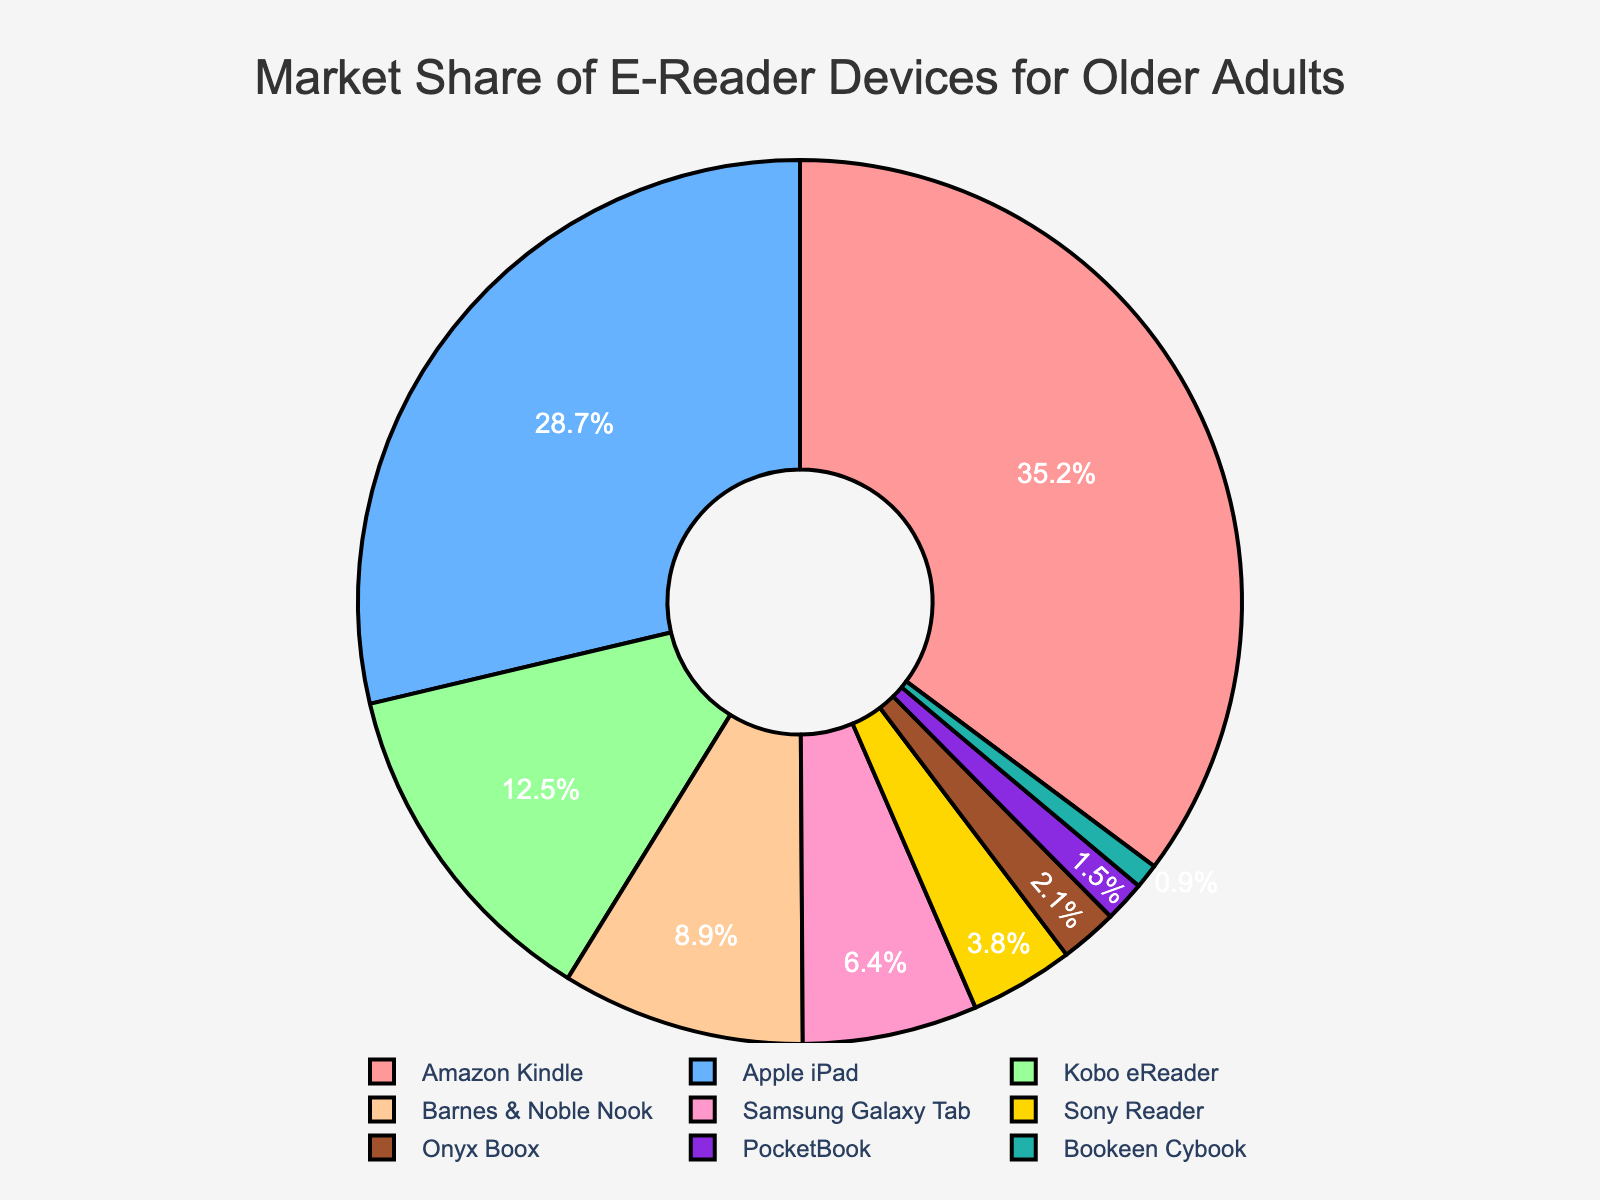Which device has the highest market share? By looking at the pie chart, the largest segment corresponds to the Amazon Kindle.
Answer: Amazon Kindle Which device has the second highest market share? The second-largest segment in the pie chart corresponds to the Apple iPad.
Answer: Apple iPad What is the combined market share of the Amazon Kindle and Apple iPad? The market share of Amazon Kindle is 35.2%, and Apple iPad is 28.7%. Adding them together gives: 35.2 + 28.7 = 63.9%.
Answer: 63.9% How much higher is the market share of the Amazon Kindle compared to the Kobo eReader? The market share of Amazon Kindle is 35.2%, and the Kobo eReader is 12.5%. Subtracting gives: 35.2 - 12.5 = 22.7%.
Answer: 22.7% Which devices have a market share of less than 5%? By inspecting the pie chart, the segments for Sony Reader, Onyx Boox, PocketBook, and Bookeen Cybook are all less than 5%.
Answer: Sony Reader, Onyx Boox, PocketBook, Bookeen Cybook What is the total market share of all devices with a market share greater than 10%? The devices with more than 10% market share are Amazon Kindle (35.2%), Apple iPad (28.7%), and Kobo eReader (12.5%). Adding them together: 35.2 + 28.7 + 12.5 = 76.4%.
Answer: 76.4% How does the market share of the Barnes & Noble Nook compare to the Samsung Galaxy Tab? The market share is Barnes & Noble Nook at 8.9%, and Samsung Galaxy Tab at 6.4%. Subtracting gives: 8.9 - 6.4 = 2.5%, so the Nook has 2.5% more market share than the Galaxy Tab.
Answer: 2.5% more What is the smallest market share represented and which device does it correspond to? The smallest market share in the pie chart corresponds to the Bookeen Cybook at 0.9%.
Answer: Bookeen Cybook What proportion of the total market do devices with a market share less than 10% collectively represent? Devices with market shares less than 10% are Kobo eReader (12.5%), Barnes & Noble Nook (8.9%), Samsung Galaxy Tab (6.4%), Sony Reader (3.8%), Onyx Boox (2.1%), PocketBook (1.5%), and Bookeen Cybook (0.9%). Adding them up: 8.9 + 6.4 + 3.8 + 2.1 + 1.5 + 0.9 = 23.6%.
Answer: 23.6% Which color represents the Sony Reader on the pie chart? Inspecting the chart, we see the Sony Reader is represented by the gold-colored segment.
Answer: Gold 